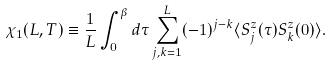Convert formula to latex. <formula><loc_0><loc_0><loc_500><loc_500>\chi _ { 1 } ( L , T ) \equiv \frac { 1 } { L } \int _ { 0 } ^ { \beta } d \tau \sum _ { j , k = 1 } ^ { L } ( - 1 ) ^ { j - k } \langle S ^ { z } _ { j } ( \tau ) S ^ { z } _ { k } ( 0 ) \rangle .</formula> 